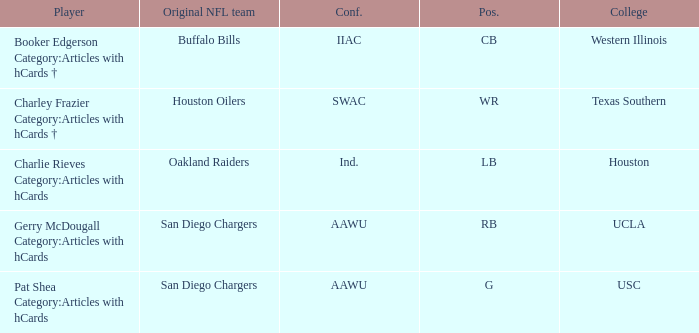What player's original team are the Oakland Raiders? Charlie Rieves Category:Articles with hCards. 